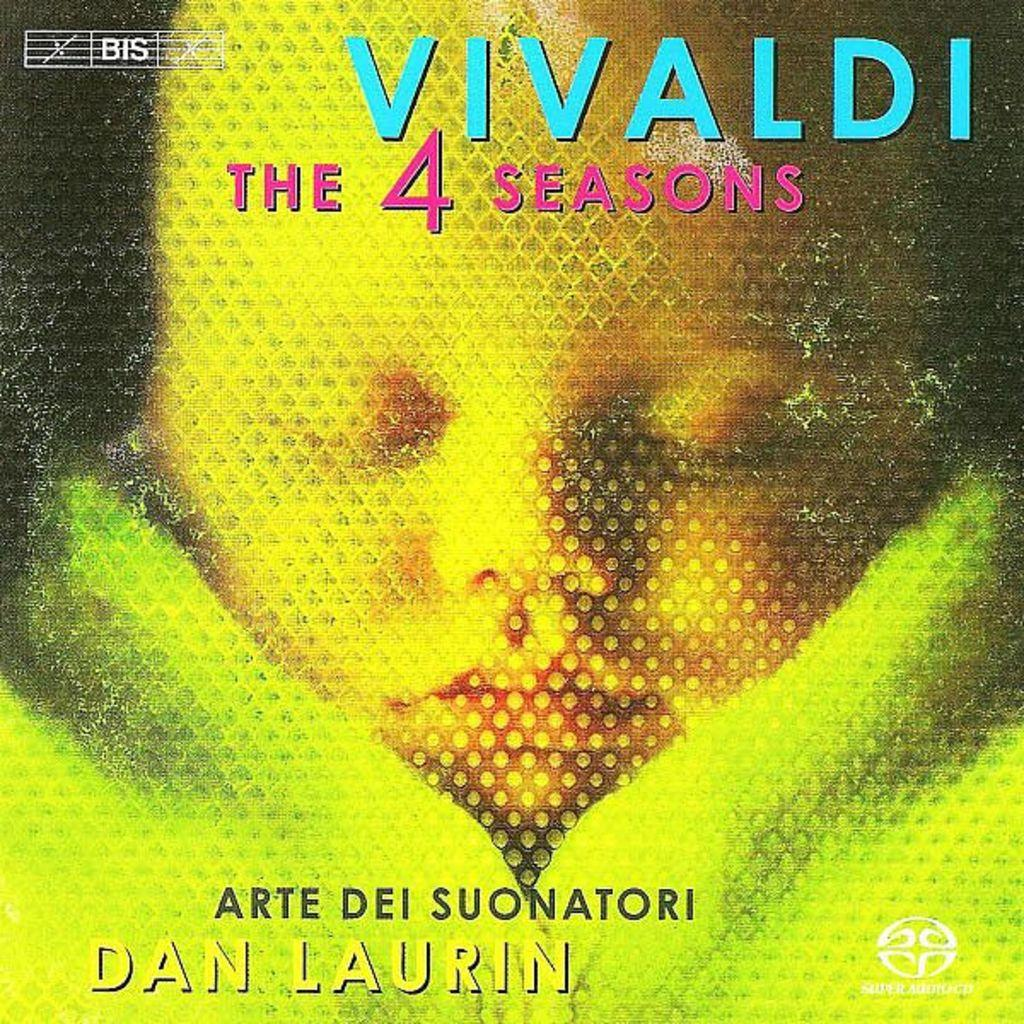<image>
Summarize the visual content of the image. magazine cover from vivaldi seasons 4 by dan laurin 